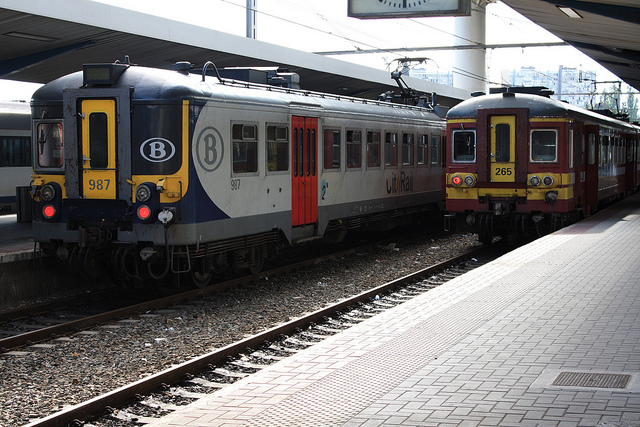What time of day does it seem to be in the photo? Judging by the shadows and the quality of the light, it appears to be either mid-morning or afternoon. The lighting is bright but not harsh, suggesting the sun is not at its peak height, as it would be around noon. 